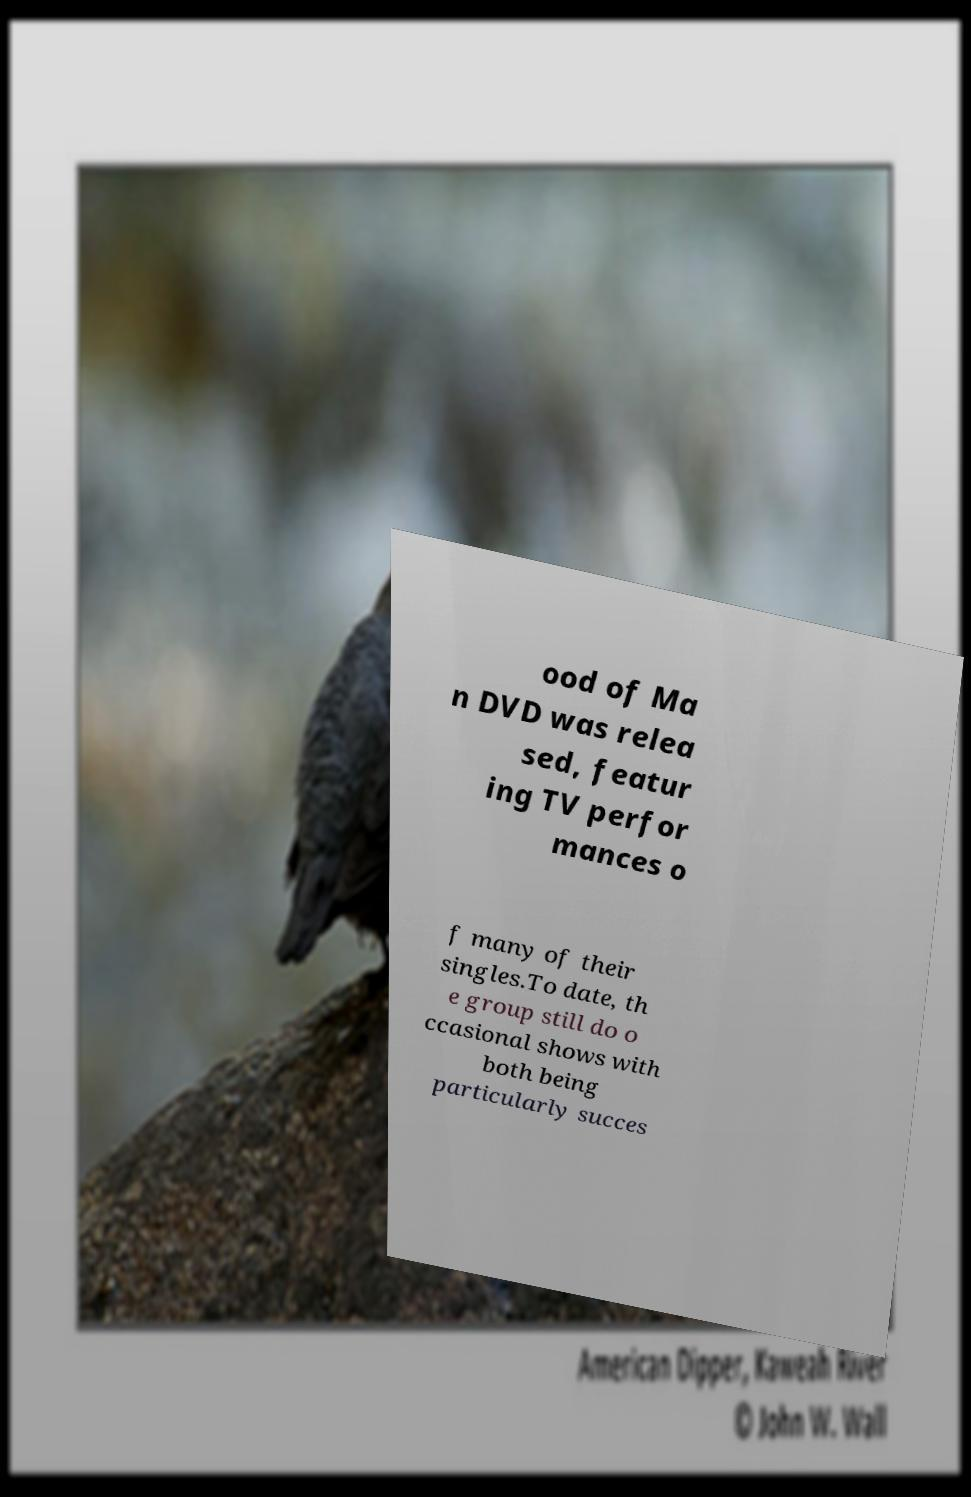Can you accurately transcribe the text from the provided image for me? ood of Ma n DVD was relea sed, featur ing TV perfor mances o f many of their singles.To date, th e group still do o ccasional shows with both being particularly succes 